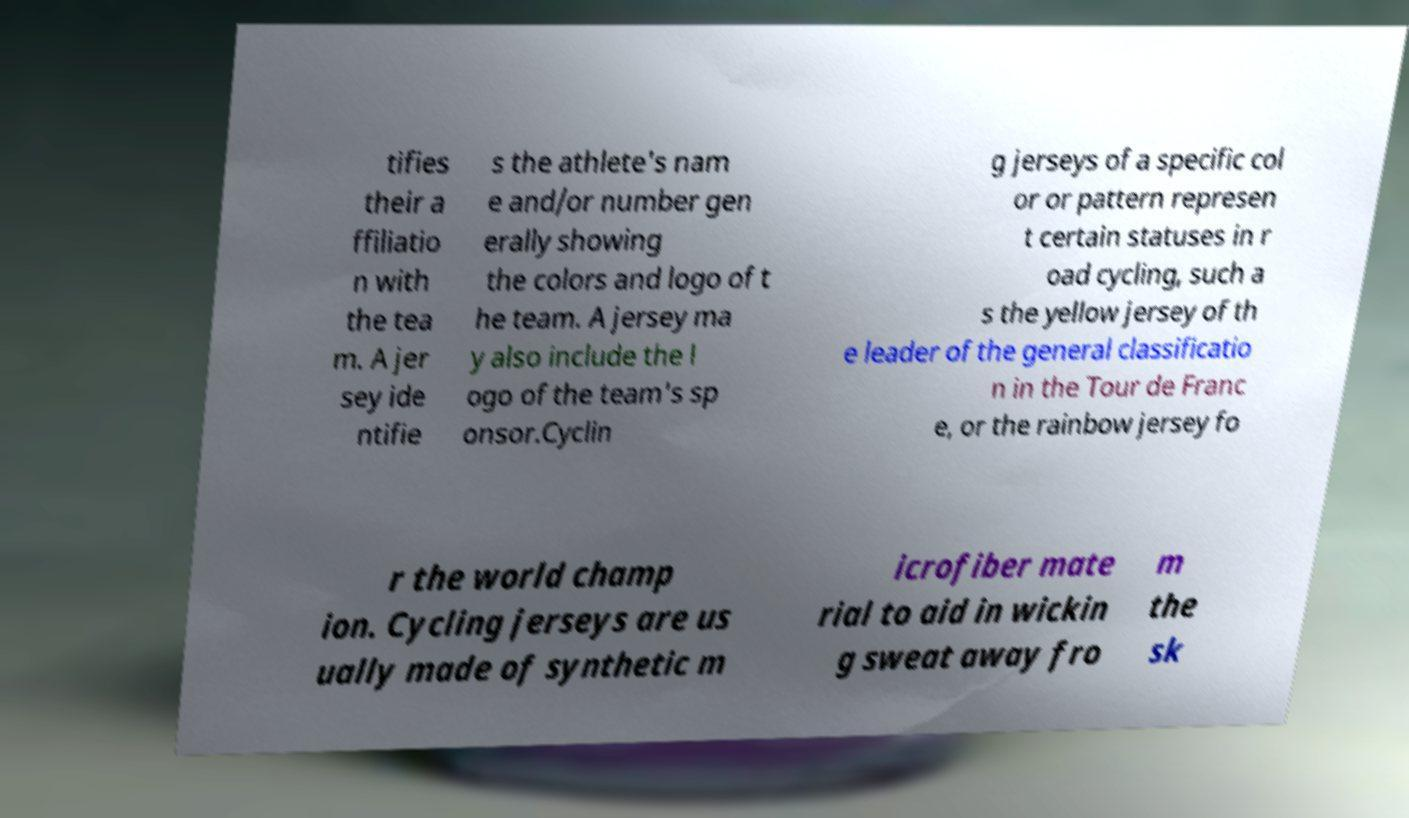Please read and relay the text visible in this image. What does it say? tifies their a ffiliatio n with the tea m. A jer sey ide ntifie s the athlete's nam e and/or number gen erally showing the colors and logo of t he team. A jersey ma y also include the l ogo of the team's sp onsor.Cyclin g jerseys of a specific col or or pattern represen t certain statuses in r oad cycling, such a s the yellow jersey of th e leader of the general classificatio n in the Tour de Franc e, or the rainbow jersey fo r the world champ ion. Cycling jerseys are us ually made of synthetic m icrofiber mate rial to aid in wickin g sweat away fro m the sk 